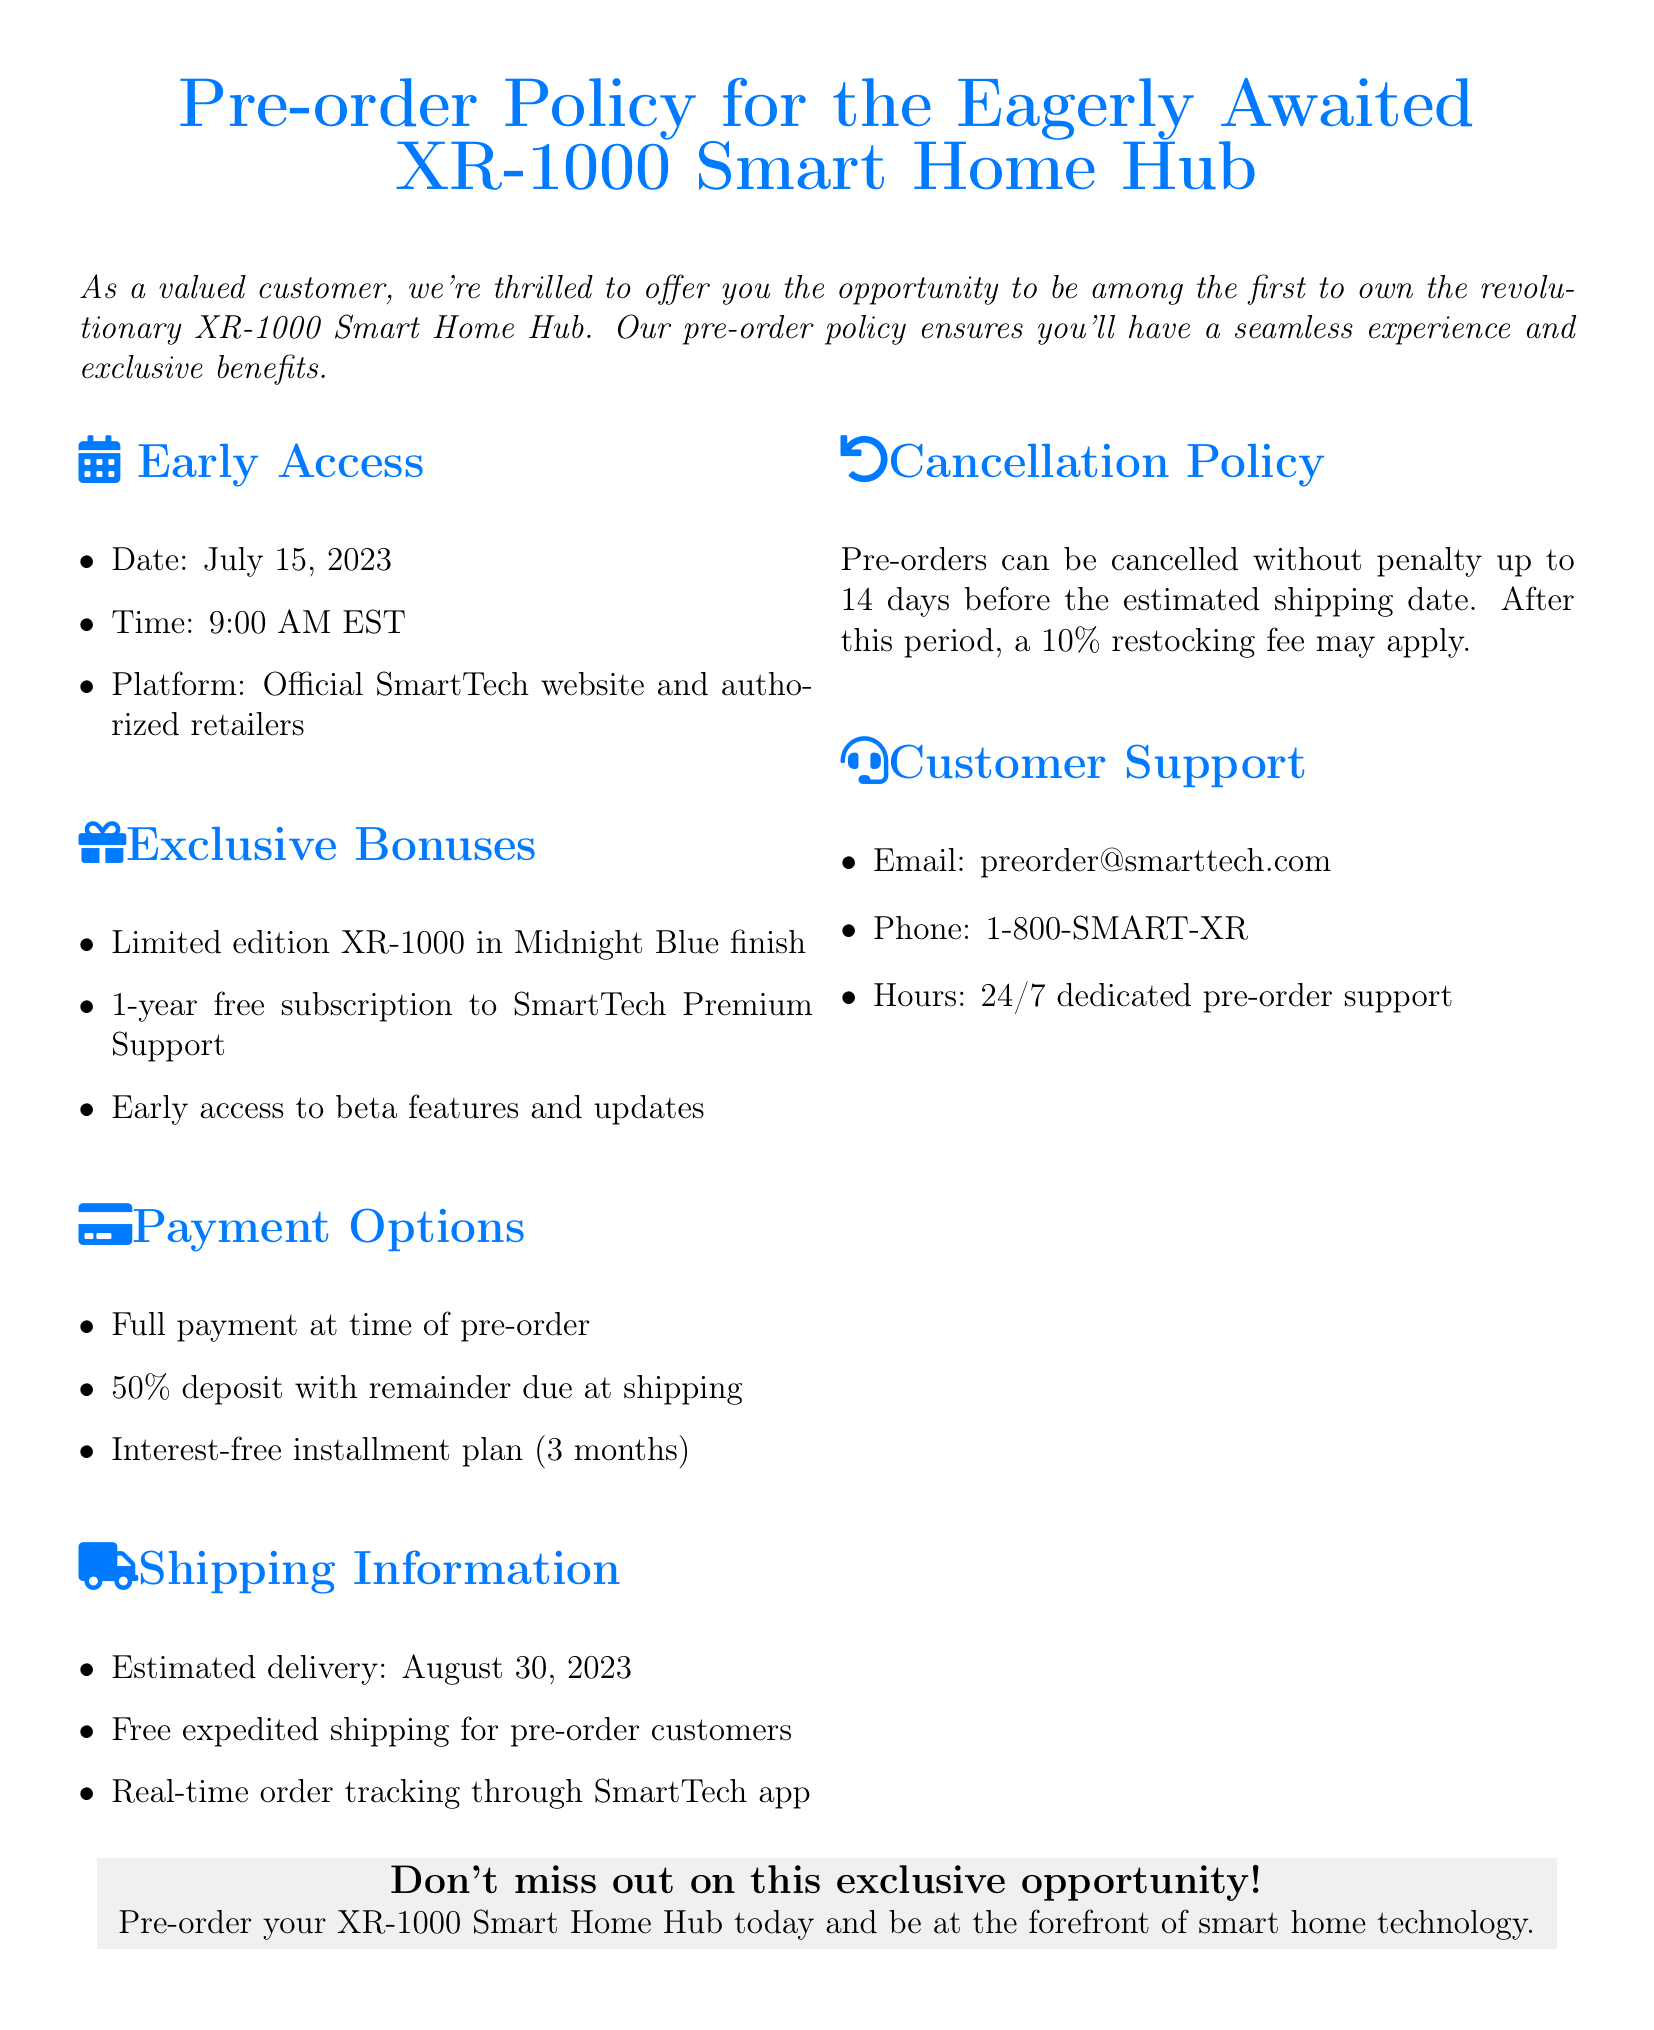What is the pre-order date? The date listed for pre-orders is July 15, 2023.
Answer: July 15, 2023 What time will pre-orders open? The pre-order time is specified as 9:00 AM EST.
Answer: 9:00 AM EST What color is the limited edition XR-1000? The pre-order document mentions the limited edition color as Midnight Blue.
Answer: Midnight Blue What is the estimated delivery date? According to the document, the estimated delivery date is August 30, 2023.
Answer: August 30, 2023 Is there a payment option for installment plans? The document lists a specific payment method that allows for interest-free installment plans over 3 months.
Answer: Interest-free installment plan (3 months) What is the cancellation fee policy after 14 days? The document states that a 10% restocking fee will apply after the 14-day cancellation period.
Answer: 10% restocking fee What bonus is included with pre-orders? A one-year free subscription to SmartTech Premium Support is one of the exclusive bonuses offered.
Answer: 1-year free subscription to SmartTech Premium Support How can customers contact support? The document provides a dedicated email for pre-order support as preorder@smarttech.com.
Answer: preorder@smarttech.com 